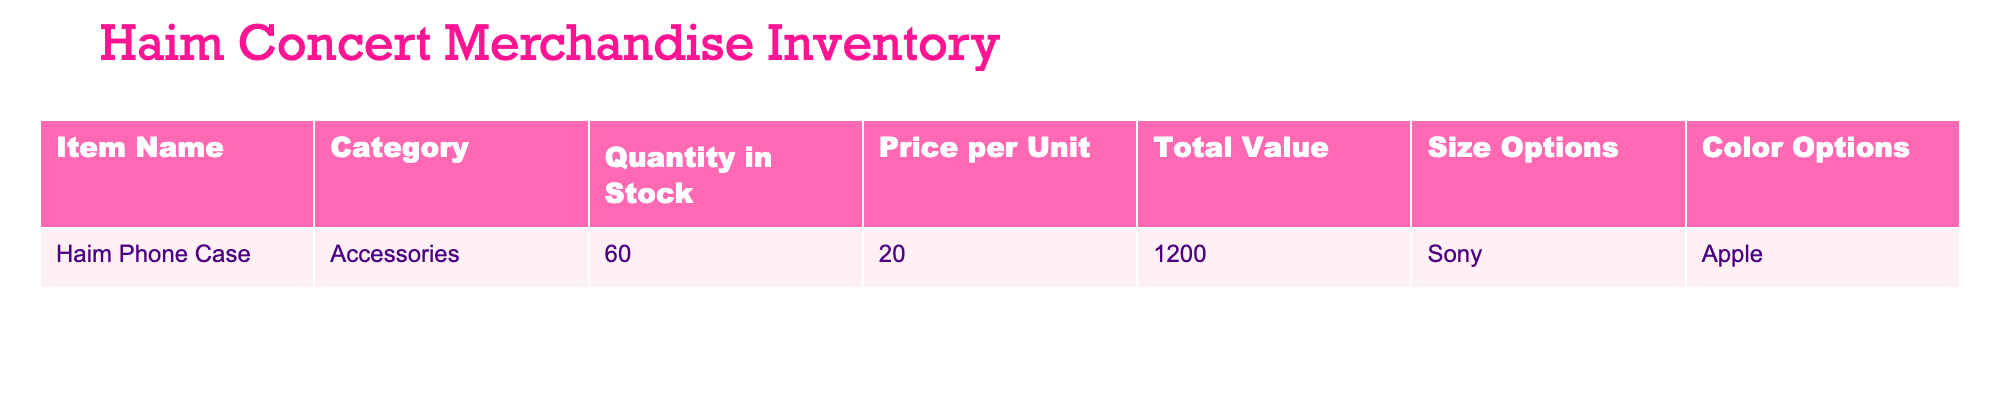What is the total value of the Haim Phone Case? The total value is explicitly listed in the table under the 'Total Value' column next to the item name 'Haim Phone Case'. The value is 1200.
Answer: 1200 How many Haim Phone Cases are in stock? The quantity in stock for the Haim Phone Case is found in the 'Quantity in Stock' column. It shows there are 60 units in stock.
Answer: 60 What is the price per unit of the Haim Phone Case? The price per unit can be found in the 'Price per Unit' column, listed next to the Haim Phone Case. It is stated as 20.
Answer: 20 Is the Haim Phone Case available in both Sony and Apple sizes? The table provides size options under 'Size Options'. Since Sony and Apple are both listed, it confirms the item is available in both sizes.
Answer: Yes If all Haim Phone Cases were sold, what would be the revenue generated? To calculate the revenue from selling all units, multiply the quantity in stock (60) by the price per unit (20). Therefore, 60 * 20 = 1200, which matches the total value stated in the table.
Answer: 1200 What is the total number of color options available for the Haim Phone Case? The 'Color Options' column is not explicitly provided in the data, implying there are no color options listed for the item. Thus, the answer is there are no options to count.
Answer: No If there were 10 additional Haim Phone Cases added to inventory, what would the new total quantity in stock be? Start with the current quantity of 60, then add the 10 new units. The calculation is 60 + 10 = 70. Therefore, the new total quantity in stock would be 70.
Answer: 70 What category does the Haim Phone Case fall under? The 'Category' column shows that the Haim Phone Case is classified under 'Accessories.' This is a direct retrieval from the table.
Answer: Accessories How much would revenue increase if the price per unit of the Haim Phone Case was increased to 25? First, calculate the new revenue with the new price: 60 units * 25 = 1500. Then, find the difference between the new revenue and the original total value of 1200: 1500 - 1200 = 300. This shows an increase of 300.
Answer: 300 